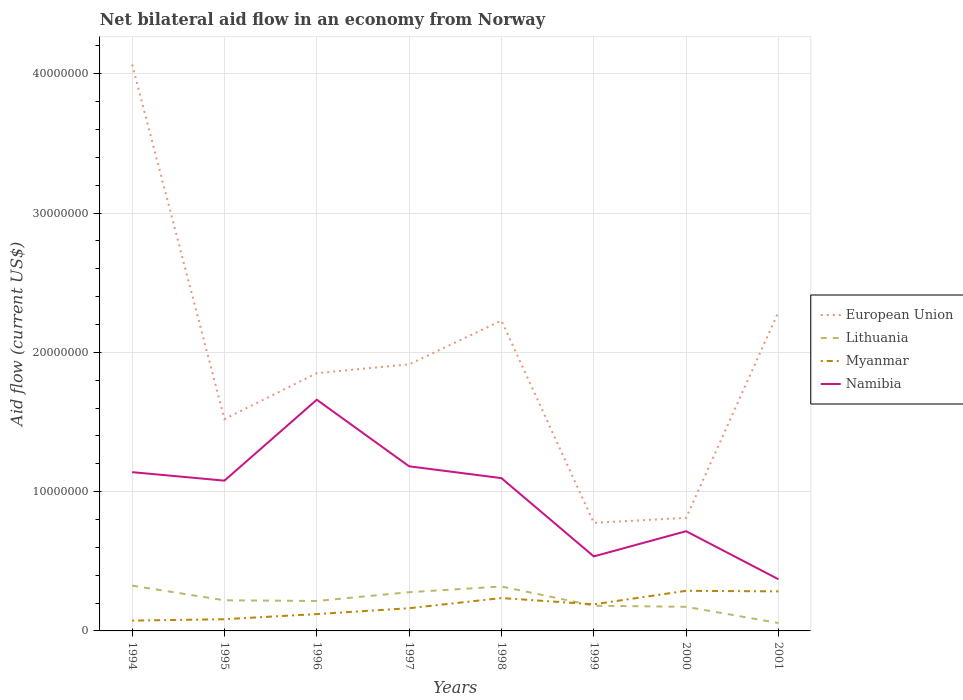Does the line corresponding to European Union intersect with the line corresponding to Lithuania?
Provide a short and direct response. No. Across all years, what is the maximum net bilateral aid flow in Myanmar?
Offer a terse response. 7.40e+05. In which year was the net bilateral aid flow in European Union maximum?
Ensure brevity in your answer.  1999. What is the total net bilateral aid flow in European Union in the graph?
Your answer should be very brief. 7.45e+06. What is the difference between the highest and the second highest net bilateral aid flow in European Union?
Your answer should be very brief. 3.29e+07. What is the difference between the highest and the lowest net bilateral aid flow in Namibia?
Your answer should be very brief. 5. How many lines are there?
Offer a very short reply. 4. What is the title of the graph?
Offer a terse response. Net bilateral aid flow in an economy from Norway. What is the label or title of the X-axis?
Your answer should be very brief. Years. What is the label or title of the Y-axis?
Keep it short and to the point. Aid flow (current US$). What is the Aid flow (current US$) in European Union in 1994?
Provide a succinct answer. 4.07e+07. What is the Aid flow (current US$) in Lithuania in 1994?
Your answer should be compact. 3.25e+06. What is the Aid flow (current US$) of Myanmar in 1994?
Make the answer very short. 7.40e+05. What is the Aid flow (current US$) of Namibia in 1994?
Your response must be concise. 1.14e+07. What is the Aid flow (current US$) of European Union in 1995?
Provide a short and direct response. 1.52e+07. What is the Aid flow (current US$) in Lithuania in 1995?
Give a very brief answer. 2.20e+06. What is the Aid flow (current US$) in Myanmar in 1995?
Your response must be concise. 8.40e+05. What is the Aid flow (current US$) of Namibia in 1995?
Give a very brief answer. 1.08e+07. What is the Aid flow (current US$) in European Union in 1996?
Ensure brevity in your answer.  1.85e+07. What is the Aid flow (current US$) in Lithuania in 1996?
Offer a terse response. 2.15e+06. What is the Aid flow (current US$) in Myanmar in 1996?
Your answer should be very brief. 1.21e+06. What is the Aid flow (current US$) of Namibia in 1996?
Offer a terse response. 1.66e+07. What is the Aid flow (current US$) of European Union in 1997?
Your answer should be very brief. 1.91e+07. What is the Aid flow (current US$) in Lithuania in 1997?
Provide a succinct answer. 2.78e+06. What is the Aid flow (current US$) in Myanmar in 1997?
Your answer should be very brief. 1.63e+06. What is the Aid flow (current US$) in Namibia in 1997?
Provide a short and direct response. 1.18e+07. What is the Aid flow (current US$) of European Union in 1998?
Provide a succinct answer. 2.23e+07. What is the Aid flow (current US$) of Lithuania in 1998?
Provide a succinct answer. 3.19e+06. What is the Aid flow (current US$) of Myanmar in 1998?
Offer a terse response. 2.36e+06. What is the Aid flow (current US$) in Namibia in 1998?
Your response must be concise. 1.10e+07. What is the Aid flow (current US$) in European Union in 1999?
Your response must be concise. 7.76e+06. What is the Aid flow (current US$) in Lithuania in 1999?
Offer a very short reply. 1.81e+06. What is the Aid flow (current US$) in Myanmar in 1999?
Offer a terse response. 1.91e+06. What is the Aid flow (current US$) in Namibia in 1999?
Ensure brevity in your answer.  5.35e+06. What is the Aid flow (current US$) of European Union in 2000?
Keep it short and to the point. 8.12e+06. What is the Aid flow (current US$) of Lithuania in 2000?
Your response must be concise. 1.73e+06. What is the Aid flow (current US$) in Myanmar in 2000?
Make the answer very short. 2.88e+06. What is the Aid flow (current US$) of Namibia in 2000?
Offer a very short reply. 7.16e+06. What is the Aid flow (current US$) of European Union in 2001?
Ensure brevity in your answer.  2.29e+07. What is the Aid flow (current US$) of Lithuania in 2001?
Your answer should be very brief. 5.70e+05. What is the Aid flow (current US$) of Myanmar in 2001?
Provide a succinct answer. 2.84e+06. What is the Aid flow (current US$) of Namibia in 2001?
Keep it short and to the point. 3.71e+06. Across all years, what is the maximum Aid flow (current US$) of European Union?
Your response must be concise. 4.07e+07. Across all years, what is the maximum Aid flow (current US$) in Lithuania?
Make the answer very short. 3.25e+06. Across all years, what is the maximum Aid flow (current US$) of Myanmar?
Give a very brief answer. 2.88e+06. Across all years, what is the maximum Aid flow (current US$) in Namibia?
Offer a very short reply. 1.66e+07. Across all years, what is the minimum Aid flow (current US$) of European Union?
Give a very brief answer. 7.76e+06. Across all years, what is the minimum Aid flow (current US$) in Lithuania?
Make the answer very short. 5.70e+05. Across all years, what is the minimum Aid flow (current US$) in Myanmar?
Your answer should be compact. 7.40e+05. Across all years, what is the minimum Aid flow (current US$) in Namibia?
Make the answer very short. 3.71e+06. What is the total Aid flow (current US$) in European Union in the graph?
Ensure brevity in your answer.  1.55e+08. What is the total Aid flow (current US$) of Lithuania in the graph?
Your response must be concise. 1.77e+07. What is the total Aid flow (current US$) in Myanmar in the graph?
Make the answer very short. 1.44e+07. What is the total Aid flow (current US$) of Namibia in the graph?
Your answer should be compact. 7.78e+07. What is the difference between the Aid flow (current US$) of European Union in 1994 and that in 1995?
Make the answer very short. 2.55e+07. What is the difference between the Aid flow (current US$) of Lithuania in 1994 and that in 1995?
Your response must be concise. 1.05e+06. What is the difference between the Aid flow (current US$) in Myanmar in 1994 and that in 1995?
Provide a succinct answer. -1.00e+05. What is the difference between the Aid flow (current US$) of European Union in 1994 and that in 1996?
Keep it short and to the point. 2.22e+07. What is the difference between the Aid flow (current US$) of Lithuania in 1994 and that in 1996?
Give a very brief answer. 1.10e+06. What is the difference between the Aid flow (current US$) in Myanmar in 1994 and that in 1996?
Provide a succinct answer. -4.70e+05. What is the difference between the Aid flow (current US$) in Namibia in 1994 and that in 1996?
Provide a succinct answer. -5.20e+06. What is the difference between the Aid flow (current US$) of European Union in 1994 and that in 1997?
Offer a very short reply. 2.15e+07. What is the difference between the Aid flow (current US$) in Myanmar in 1994 and that in 1997?
Your response must be concise. -8.90e+05. What is the difference between the Aid flow (current US$) of Namibia in 1994 and that in 1997?
Provide a succinct answer. -4.20e+05. What is the difference between the Aid flow (current US$) in European Union in 1994 and that in 1998?
Provide a succinct answer. 1.84e+07. What is the difference between the Aid flow (current US$) in Myanmar in 1994 and that in 1998?
Ensure brevity in your answer.  -1.62e+06. What is the difference between the Aid flow (current US$) in Namibia in 1994 and that in 1998?
Offer a very short reply. 4.30e+05. What is the difference between the Aid flow (current US$) of European Union in 1994 and that in 1999?
Make the answer very short. 3.29e+07. What is the difference between the Aid flow (current US$) of Lithuania in 1994 and that in 1999?
Provide a succinct answer. 1.44e+06. What is the difference between the Aid flow (current US$) of Myanmar in 1994 and that in 1999?
Ensure brevity in your answer.  -1.17e+06. What is the difference between the Aid flow (current US$) of Namibia in 1994 and that in 1999?
Provide a succinct answer. 6.05e+06. What is the difference between the Aid flow (current US$) in European Union in 1994 and that in 2000?
Provide a short and direct response. 3.26e+07. What is the difference between the Aid flow (current US$) in Lithuania in 1994 and that in 2000?
Offer a terse response. 1.52e+06. What is the difference between the Aid flow (current US$) in Myanmar in 1994 and that in 2000?
Offer a very short reply. -2.14e+06. What is the difference between the Aid flow (current US$) in Namibia in 1994 and that in 2000?
Provide a succinct answer. 4.24e+06. What is the difference between the Aid flow (current US$) in European Union in 1994 and that in 2001?
Provide a short and direct response. 1.78e+07. What is the difference between the Aid flow (current US$) of Lithuania in 1994 and that in 2001?
Offer a very short reply. 2.68e+06. What is the difference between the Aid flow (current US$) in Myanmar in 1994 and that in 2001?
Make the answer very short. -2.10e+06. What is the difference between the Aid flow (current US$) of Namibia in 1994 and that in 2001?
Provide a short and direct response. 7.69e+06. What is the difference between the Aid flow (current US$) in European Union in 1995 and that in 1996?
Ensure brevity in your answer.  -3.30e+06. What is the difference between the Aid flow (current US$) in Lithuania in 1995 and that in 1996?
Your response must be concise. 5.00e+04. What is the difference between the Aid flow (current US$) in Myanmar in 1995 and that in 1996?
Offer a terse response. -3.70e+05. What is the difference between the Aid flow (current US$) of Namibia in 1995 and that in 1996?
Provide a succinct answer. -5.81e+06. What is the difference between the Aid flow (current US$) of European Union in 1995 and that in 1997?
Offer a terse response. -3.93e+06. What is the difference between the Aid flow (current US$) in Lithuania in 1995 and that in 1997?
Your answer should be very brief. -5.80e+05. What is the difference between the Aid flow (current US$) in Myanmar in 1995 and that in 1997?
Offer a terse response. -7.90e+05. What is the difference between the Aid flow (current US$) in Namibia in 1995 and that in 1997?
Offer a terse response. -1.03e+06. What is the difference between the Aid flow (current US$) in European Union in 1995 and that in 1998?
Give a very brief answer. -7.07e+06. What is the difference between the Aid flow (current US$) in Lithuania in 1995 and that in 1998?
Make the answer very short. -9.90e+05. What is the difference between the Aid flow (current US$) in Myanmar in 1995 and that in 1998?
Make the answer very short. -1.52e+06. What is the difference between the Aid flow (current US$) of Namibia in 1995 and that in 1998?
Keep it short and to the point. -1.80e+05. What is the difference between the Aid flow (current US$) in European Union in 1995 and that in 1999?
Offer a terse response. 7.45e+06. What is the difference between the Aid flow (current US$) in Myanmar in 1995 and that in 1999?
Your answer should be compact. -1.07e+06. What is the difference between the Aid flow (current US$) of Namibia in 1995 and that in 1999?
Your answer should be compact. 5.44e+06. What is the difference between the Aid flow (current US$) of European Union in 1995 and that in 2000?
Offer a very short reply. 7.09e+06. What is the difference between the Aid flow (current US$) of Lithuania in 1995 and that in 2000?
Give a very brief answer. 4.70e+05. What is the difference between the Aid flow (current US$) of Myanmar in 1995 and that in 2000?
Make the answer very short. -2.04e+06. What is the difference between the Aid flow (current US$) of Namibia in 1995 and that in 2000?
Make the answer very short. 3.63e+06. What is the difference between the Aid flow (current US$) of European Union in 1995 and that in 2001?
Provide a short and direct response. -7.70e+06. What is the difference between the Aid flow (current US$) of Lithuania in 1995 and that in 2001?
Give a very brief answer. 1.63e+06. What is the difference between the Aid flow (current US$) of Namibia in 1995 and that in 2001?
Your answer should be compact. 7.08e+06. What is the difference between the Aid flow (current US$) of European Union in 1996 and that in 1997?
Keep it short and to the point. -6.30e+05. What is the difference between the Aid flow (current US$) of Lithuania in 1996 and that in 1997?
Ensure brevity in your answer.  -6.30e+05. What is the difference between the Aid flow (current US$) of Myanmar in 1996 and that in 1997?
Ensure brevity in your answer.  -4.20e+05. What is the difference between the Aid flow (current US$) in Namibia in 1996 and that in 1997?
Your answer should be compact. 4.78e+06. What is the difference between the Aid flow (current US$) of European Union in 1996 and that in 1998?
Offer a terse response. -3.77e+06. What is the difference between the Aid flow (current US$) of Lithuania in 1996 and that in 1998?
Give a very brief answer. -1.04e+06. What is the difference between the Aid flow (current US$) of Myanmar in 1996 and that in 1998?
Keep it short and to the point. -1.15e+06. What is the difference between the Aid flow (current US$) in Namibia in 1996 and that in 1998?
Provide a short and direct response. 5.63e+06. What is the difference between the Aid flow (current US$) in European Union in 1996 and that in 1999?
Offer a terse response. 1.08e+07. What is the difference between the Aid flow (current US$) of Myanmar in 1996 and that in 1999?
Offer a terse response. -7.00e+05. What is the difference between the Aid flow (current US$) of Namibia in 1996 and that in 1999?
Provide a short and direct response. 1.12e+07. What is the difference between the Aid flow (current US$) in European Union in 1996 and that in 2000?
Provide a short and direct response. 1.04e+07. What is the difference between the Aid flow (current US$) of Lithuania in 1996 and that in 2000?
Keep it short and to the point. 4.20e+05. What is the difference between the Aid flow (current US$) of Myanmar in 1996 and that in 2000?
Give a very brief answer. -1.67e+06. What is the difference between the Aid flow (current US$) of Namibia in 1996 and that in 2000?
Your response must be concise. 9.44e+06. What is the difference between the Aid flow (current US$) in European Union in 1996 and that in 2001?
Your response must be concise. -4.40e+06. What is the difference between the Aid flow (current US$) in Lithuania in 1996 and that in 2001?
Your answer should be compact. 1.58e+06. What is the difference between the Aid flow (current US$) in Myanmar in 1996 and that in 2001?
Keep it short and to the point. -1.63e+06. What is the difference between the Aid flow (current US$) in Namibia in 1996 and that in 2001?
Your response must be concise. 1.29e+07. What is the difference between the Aid flow (current US$) of European Union in 1997 and that in 1998?
Ensure brevity in your answer.  -3.14e+06. What is the difference between the Aid flow (current US$) of Lithuania in 1997 and that in 1998?
Provide a succinct answer. -4.10e+05. What is the difference between the Aid flow (current US$) in Myanmar in 1997 and that in 1998?
Offer a terse response. -7.30e+05. What is the difference between the Aid flow (current US$) in Namibia in 1997 and that in 1998?
Offer a terse response. 8.50e+05. What is the difference between the Aid flow (current US$) of European Union in 1997 and that in 1999?
Your response must be concise. 1.14e+07. What is the difference between the Aid flow (current US$) in Lithuania in 1997 and that in 1999?
Offer a very short reply. 9.70e+05. What is the difference between the Aid flow (current US$) of Myanmar in 1997 and that in 1999?
Your response must be concise. -2.80e+05. What is the difference between the Aid flow (current US$) of Namibia in 1997 and that in 1999?
Give a very brief answer. 6.47e+06. What is the difference between the Aid flow (current US$) of European Union in 1997 and that in 2000?
Make the answer very short. 1.10e+07. What is the difference between the Aid flow (current US$) of Lithuania in 1997 and that in 2000?
Your response must be concise. 1.05e+06. What is the difference between the Aid flow (current US$) of Myanmar in 1997 and that in 2000?
Give a very brief answer. -1.25e+06. What is the difference between the Aid flow (current US$) in Namibia in 1997 and that in 2000?
Provide a short and direct response. 4.66e+06. What is the difference between the Aid flow (current US$) of European Union in 1997 and that in 2001?
Offer a terse response. -3.77e+06. What is the difference between the Aid flow (current US$) in Lithuania in 1997 and that in 2001?
Ensure brevity in your answer.  2.21e+06. What is the difference between the Aid flow (current US$) of Myanmar in 1997 and that in 2001?
Your answer should be very brief. -1.21e+06. What is the difference between the Aid flow (current US$) in Namibia in 1997 and that in 2001?
Your response must be concise. 8.11e+06. What is the difference between the Aid flow (current US$) of European Union in 1998 and that in 1999?
Provide a succinct answer. 1.45e+07. What is the difference between the Aid flow (current US$) of Lithuania in 1998 and that in 1999?
Ensure brevity in your answer.  1.38e+06. What is the difference between the Aid flow (current US$) in Namibia in 1998 and that in 1999?
Your answer should be compact. 5.62e+06. What is the difference between the Aid flow (current US$) of European Union in 1998 and that in 2000?
Give a very brief answer. 1.42e+07. What is the difference between the Aid flow (current US$) in Lithuania in 1998 and that in 2000?
Keep it short and to the point. 1.46e+06. What is the difference between the Aid flow (current US$) in Myanmar in 1998 and that in 2000?
Give a very brief answer. -5.20e+05. What is the difference between the Aid flow (current US$) of Namibia in 1998 and that in 2000?
Offer a terse response. 3.81e+06. What is the difference between the Aid flow (current US$) of European Union in 1998 and that in 2001?
Your answer should be compact. -6.30e+05. What is the difference between the Aid flow (current US$) in Lithuania in 1998 and that in 2001?
Provide a succinct answer. 2.62e+06. What is the difference between the Aid flow (current US$) in Myanmar in 1998 and that in 2001?
Provide a succinct answer. -4.80e+05. What is the difference between the Aid flow (current US$) of Namibia in 1998 and that in 2001?
Make the answer very short. 7.26e+06. What is the difference between the Aid flow (current US$) in European Union in 1999 and that in 2000?
Provide a succinct answer. -3.60e+05. What is the difference between the Aid flow (current US$) of Lithuania in 1999 and that in 2000?
Your response must be concise. 8.00e+04. What is the difference between the Aid flow (current US$) of Myanmar in 1999 and that in 2000?
Provide a short and direct response. -9.70e+05. What is the difference between the Aid flow (current US$) of Namibia in 1999 and that in 2000?
Offer a terse response. -1.81e+06. What is the difference between the Aid flow (current US$) in European Union in 1999 and that in 2001?
Make the answer very short. -1.52e+07. What is the difference between the Aid flow (current US$) in Lithuania in 1999 and that in 2001?
Provide a succinct answer. 1.24e+06. What is the difference between the Aid flow (current US$) in Myanmar in 1999 and that in 2001?
Provide a short and direct response. -9.30e+05. What is the difference between the Aid flow (current US$) in Namibia in 1999 and that in 2001?
Provide a succinct answer. 1.64e+06. What is the difference between the Aid flow (current US$) in European Union in 2000 and that in 2001?
Offer a very short reply. -1.48e+07. What is the difference between the Aid flow (current US$) in Lithuania in 2000 and that in 2001?
Your answer should be compact. 1.16e+06. What is the difference between the Aid flow (current US$) in Myanmar in 2000 and that in 2001?
Keep it short and to the point. 4.00e+04. What is the difference between the Aid flow (current US$) of Namibia in 2000 and that in 2001?
Offer a very short reply. 3.45e+06. What is the difference between the Aid flow (current US$) in European Union in 1994 and the Aid flow (current US$) in Lithuania in 1995?
Your answer should be very brief. 3.85e+07. What is the difference between the Aid flow (current US$) of European Union in 1994 and the Aid flow (current US$) of Myanmar in 1995?
Offer a terse response. 3.98e+07. What is the difference between the Aid flow (current US$) of European Union in 1994 and the Aid flow (current US$) of Namibia in 1995?
Provide a succinct answer. 2.99e+07. What is the difference between the Aid flow (current US$) in Lithuania in 1994 and the Aid flow (current US$) in Myanmar in 1995?
Provide a succinct answer. 2.41e+06. What is the difference between the Aid flow (current US$) in Lithuania in 1994 and the Aid flow (current US$) in Namibia in 1995?
Your answer should be very brief. -7.54e+06. What is the difference between the Aid flow (current US$) of Myanmar in 1994 and the Aid flow (current US$) of Namibia in 1995?
Offer a terse response. -1.00e+07. What is the difference between the Aid flow (current US$) of European Union in 1994 and the Aid flow (current US$) of Lithuania in 1996?
Your answer should be very brief. 3.85e+07. What is the difference between the Aid flow (current US$) of European Union in 1994 and the Aid flow (current US$) of Myanmar in 1996?
Give a very brief answer. 3.95e+07. What is the difference between the Aid flow (current US$) in European Union in 1994 and the Aid flow (current US$) in Namibia in 1996?
Make the answer very short. 2.41e+07. What is the difference between the Aid flow (current US$) in Lithuania in 1994 and the Aid flow (current US$) in Myanmar in 1996?
Your response must be concise. 2.04e+06. What is the difference between the Aid flow (current US$) of Lithuania in 1994 and the Aid flow (current US$) of Namibia in 1996?
Your answer should be very brief. -1.34e+07. What is the difference between the Aid flow (current US$) of Myanmar in 1994 and the Aid flow (current US$) of Namibia in 1996?
Your response must be concise. -1.59e+07. What is the difference between the Aid flow (current US$) in European Union in 1994 and the Aid flow (current US$) in Lithuania in 1997?
Ensure brevity in your answer.  3.79e+07. What is the difference between the Aid flow (current US$) in European Union in 1994 and the Aid flow (current US$) in Myanmar in 1997?
Ensure brevity in your answer.  3.90e+07. What is the difference between the Aid flow (current US$) of European Union in 1994 and the Aid flow (current US$) of Namibia in 1997?
Keep it short and to the point. 2.88e+07. What is the difference between the Aid flow (current US$) in Lithuania in 1994 and the Aid flow (current US$) in Myanmar in 1997?
Keep it short and to the point. 1.62e+06. What is the difference between the Aid flow (current US$) of Lithuania in 1994 and the Aid flow (current US$) of Namibia in 1997?
Your answer should be very brief. -8.57e+06. What is the difference between the Aid flow (current US$) in Myanmar in 1994 and the Aid flow (current US$) in Namibia in 1997?
Give a very brief answer. -1.11e+07. What is the difference between the Aid flow (current US$) in European Union in 1994 and the Aid flow (current US$) in Lithuania in 1998?
Provide a short and direct response. 3.75e+07. What is the difference between the Aid flow (current US$) of European Union in 1994 and the Aid flow (current US$) of Myanmar in 1998?
Give a very brief answer. 3.83e+07. What is the difference between the Aid flow (current US$) of European Union in 1994 and the Aid flow (current US$) of Namibia in 1998?
Your answer should be very brief. 2.97e+07. What is the difference between the Aid flow (current US$) in Lithuania in 1994 and the Aid flow (current US$) in Myanmar in 1998?
Offer a terse response. 8.90e+05. What is the difference between the Aid flow (current US$) of Lithuania in 1994 and the Aid flow (current US$) of Namibia in 1998?
Make the answer very short. -7.72e+06. What is the difference between the Aid flow (current US$) of Myanmar in 1994 and the Aid flow (current US$) of Namibia in 1998?
Keep it short and to the point. -1.02e+07. What is the difference between the Aid flow (current US$) in European Union in 1994 and the Aid flow (current US$) in Lithuania in 1999?
Provide a short and direct response. 3.89e+07. What is the difference between the Aid flow (current US$) in European Union in 1994 and the Aid flow (current US$) in Myanmar in 1999?
Your response must be concise. 3.88e+07. What is the difference between the Aid flow (current US$) of European Union in 1994 and the Aid flow (current US$) of Namibia in 1999?
Offer a terse response. 3.53e+07. What is the difference between the Aid flow (current US$) in Lithuania in 1994 and the Aid flow (current US$) in Myanmar in 1999?
Give a very brief answer. 1.34e+06. What is the difference between the Aid flow (current US$) of Lithuania in 1994 and the Aid flow (current US$) of Namibia in 1999?
Ensure brevity in your answer.  -2.10e+06. What is the difference between the Aid flow (current US$) of Myanmar in 1994 and the Aid flow (current US$) of Namibia in 1999?
Provide a succinct answer. -4.61e+06. What is the difference between the Aid flow (current US$) in European Union in 1994 and the Aid flow (current US$) in Lithuania in 2000?
Ensure brevity in your answer.  3.89e+07. What is the difference between the Aid flow (current US$) in European Union in 1994 and the Aid flow (current US$) in Myanmar in 2000?
Ensure brevity in your answer.  3.78e+07. What is the difference between the Aid flow (current US$) in European Union in 1994 and the Aid flow (current US$) in Namibia in 2000?
Give a very brief answer. 3.35e+07. What is the difference between the Aid flow (current US$) in Lithuania in 1994 and the Aid flow (current US$) in Namibia in 2000?
Your answer should be compact. -3.91e+06. What is the difference between the Aid flow (current US$) in Myanmar in 1994 and the Aid flow (current US$) in Namibia in 2000?
Provide a succinct answer. -6.42e+06. What is the difference between the Aid flow (current US$) in European Union in 1994 and the Aid flow (current US$) in Lithuania in 2001?
Provide a succinct answer. 4.01e+07. What is the difference between the Aid flow (current US$) of European Union in 1994 and the Aid flow (current US$) of Myanmar in 2001?
Offer a terse response. 3.78e+07. What is the difference between the Aid flow (current US$) of European Union in 1994 and the Aid flow (current US$) of Namibia in 2001?
Make the answer very short. 3.70e+07. What is the difference between the Aid flow (current US$) of Lithuania in 1994 and the Aid flow (current US$) of Myanmar in 2001?
Provide a short and direct response. 4.10e+05. What is the difference between the Aid flow (current US$) in Lithuania in 1994 and the Aid flow (current US$) in Namibia in 2001?
Offer a terse response. -4.60e+05. What is the difference between the Aid flow (current US$) of Myanmar in 1994 and the Aid flow (current US$) of Namibia in 2001?
Your answer should be compact. -2.97e+06. What is the difference between the Aid flow (current US$) of European Union in 1995 and the Aid flow (current US$) of Lithuania in 1996?
Your response must be concise. 1.31e+07. What is the difference between the Aid flow (current US$) in European Union in 1995 and the Aid flow (current US$) in Myanmar in 1996?
Make the answer very short. 1.40e+07. What is the difference between the Aid flow (current US$) of European Union in 1995 and the Aid flow (current US$) of Namibia in 1996?
Make the answer very short. -1.39e+06. What is the difference between the Aid flow (current US$) of Lithuania in 1995 and the Aid flow (current US$) of Myanmar in 1996?
Your answer should be very brief. 9.90e+05. What is the difference between the Aid flow (current US$) in Lithuania in 1995 and the Aid flow (current US$) in Namibia in 1996?
Provide a succinct answer. -1.44e+07. What is the difference between the Aid flow (current US$) in Myanmar in 1995 and the Aid flow (current US$) in Namibia in 1996?
Provide a short and direct response. -1.58e+07. What is the difference between the Aid flow (current US$) of European Union in 1995 and the Aid flow (current US$) of Lithuania in 1997?
Keep it short and to the point. 1.24e+07. What is the difference between the Aid flow (current US$) of European Union in 1995 and the Aid flow (current US$) of Myanmar in 1997?
Offer a very short reply. 1.36e+07. What is the difference between the Aid flow (current US$) in European Union in 1995 and the Aid flow (current US$) in Namibia in 1997?
Your answer should be very brief. 3.39e+06. What is the difference between the Aid flow (current US$) of Lithuania in 1995 and the Aid flow (current US$) of Myanmar in 1997?
Ensure brevity in your answer.  5.70e+05. What is the difference between the Aid flow (current US$) of Lithuania in 1995 and the Aid flow (current US$) of Namibia in 1997?
Provide a short and direct response. -9.62e+06. What is the difference between the Aid flow (current US$) of Myanmar in 1995 and the Aid flow (current US$) of Namibia in 1997?
Keep it short and to the point. -1.10e+07. What is the difference between the Aid flow (current US$) in European Union in 1995 and the Aid flow (current US$) in Lithuania in 1998?
Your answer should be compact. 1.20e+07. What is the difference between the Aid flow (current US$) in European Union in 1995 and the Aid flow (current US$) in Myanmar in 1998?
Provide a short and direct response. 1.28e+07. What is the difference between the Aid flow (current US$) in European Union in 1995 and the Aid flow (current US$) in Namibia in 1998?
Your answer should be compact. 4.24e+06. What is the difference between the Aid flow (current US$) in Lithuania in 1995 and the Aid flow (current US$) in Namibia in 1998?
Give a very brief answer. -8.77e+06. What is the difference between the Aid flow (current US$) in Myanmar in 1995 and the Aid flow (current US$) in Namibia in 1998?
Give a very brief answer. -1.01e+07. What is the difference between the Aid flow (current US$) of European Union in 1995 and the Aid flow (current US$) of Lithuania in 1999?
Offer a terse response. 1.34e+07. What is the difference between the Aid flow (current US$) in European Union in 1995 and the Aid flow (current US$) in Myanmar in 1999?
Make the answer very short. 1.33e+07. What is the difference between the Aid flow (current US$) of European Union in 1995 and the Aid flow (current US$) of Namibia in 1999?
Your answer should be very brief. 9.86e+06. What is the difference between the Aid flow (current US$) of Lithuania in 1995 and the Aid flow (current US$) of Namibia in 1999?
Keep it short and to the point. -3.15e+06. What is the difference between the Aid flow (current US$) in Myanmar in 1995 and the Aid flow (current US$) in Namibia in 1999?
Provide a short and direct response. -4.51e+06. What is the difference between the Aid flow (current US$) of European Union in 1995 and the Aid flow (current US$) of Lithuania in 2000?
Offer a terse response. 1.35e+07. What is the difference between the Aid flow (current US$) of European Union in 1995 and the Aid flow (current US$) of Myanmar in 2000?
Provide a short and direct response. 1.23e+07. What is the difference between the Aid flow (current US$) in European Union in 1995 and the Aid flow (current US$) in Namibia in 2000?
Offer a very short reply. 8.05e+06. What is the difference between the Aid flow (current US$) of Lithuania in 1995 and the Aid flow (current US$) of Myanmar in 2000?
Provide a short and direct response. -6.80e+05. What is the difference between the Aid flow (current US$) in Lithuania in 1995 and the Aid flow (current US$) in Namibia in 2000?
Your answer should be compact. -4.96e+06. What is the difference between the Aid flow (current US$) in Myanmar in 1995 and the Aid flow (current US$) in Namibia in 2000?
Offer a terse response. -6.32e+06. What is the difference between the Aid flow (current US$) in European Union in 1995 and the Aid flow (current US$) in Lithuania in 2001?
Your response must be concise. 1.46e+07. What is the difference between the Aid flow (current US$) in European Union in 1995 and the Aid flow (current US$) in Myanmar in 2001?
Make the answer very short. 1.24e+07. What is the difference between the Aid flow (current US$) in European Union in 1995 and the Aid flow (current US$) in Namibia in 2001?
Your answer should be very brief. 1.15e+07. What is the difference between the Aid flow (current US$) of Lithuania in 1995 and the Aid flow (current US$) of Myanmar in 2001?
Your response must be concise. -6.40e+05. What is the difference between the Aid flow (current US$) of Lithuania in 1995 and the Aid flow (current US$) of Namibia in 2001?
Provide a succinct answer. -1.51e+06. What is the difference between the Aid flow (current US$) in Myanmar in 1995 and the Aid flow (current US$) in Namibia in 2001?
Provide a short and direct response. -2.87e+06. What is the difference between the Aid flow (current US$) in European Union in 1996 and the Aid flow (current US$) in Lithuania in 1997?
Keep it short and to the point. 1.57e+07. What is the difference between the Aid flow (current US$) in European Union in 1996 and the Aid flow (current US$) in Myanmar in 1997?
Give a very brief answer. 1.69e+07. What is the difference between the Aid flow (current US$) of European Union in 1996 and the Aid flow (current US$) of Namibia in 1997?
Keep it short and to the point. 6.69e+06. What is the difference between the Aid flow (current US$) of Lithuania in 1996 and the Aid flow (current US$) of Myanmar in 1997?
Ensure brevity in your answer.  5.20e+05. What is the difference between the Aid flow (current US$) in Lithuania in 1996 and the Aid flow (current US$) in Namibia in 1997?
Provide a short and direct response. -9.67e+06. What is the difference between the Aid flow (current US$) of Myanmar in 1996 and the Aid flow (current US$) of Namibia in 1997?
Your response must be concise. -1.06e+07. What is the difference between the Aid flow (current US$) in European Union in 1996 and the Aid flow (current US$) in Lithuania in 1998?
Make the answer very short. 1.53e+07. What is the difference between the Aid flow (current US$) in European Union in 1996 and the Aid flow (current US$) in Myanmar in 1998?
Offer a terse response. 1.62e+07. What is the difference between the Aid flow (current US$) of European Union in 1996 and the Aid flow (current US$) of Namibia in 1998?
Provide a short and direct response. 7.54e+06. What is the difference between the Aid flow (current US$) in Lithuania in 1996 and the Aid flow (current US$) in Myanmar in 1998?
Your response must be concise. -2.10e+05. What is the difference between the Aid flow (current US$) in Lithuania in 1996 and the Aid flow (current US$) in Namibia in 1998?
Give a very brief answer. -8.82e+06. What is the difference between the Aid flow (current US$) of Myanmar in 1996 and the Aid flow (current US$) of Namibia in 1998?
Ensure brevity in your answer.  -9.76e+06. What is the difference between the Aid flow (current US$) of European Union in 1996 and the Aid flow (current US$) of Lithuania in 1999?
Provide a short and direct response. 1.67e+07. What is the difference between the Aid flow (current US$) in European Union in 1996 and the Aid flow (current US$) in Myanmar in 1999?
Your answer should be very brief. 1.66e+07. What is the difference between the Aid flow (current US$) in European Union in 1996 and the Aid flow (current US$) in Namibia in 1999?
Your answer should be compact. 1.32e+07. What is the difference between the Aid flow (current US$) of Lithuania in 1996 and the Aid flow (current US$) of Namibia in 1999?
Keep it short and to the point. -3.20e+06. What is the difference between the Aid flow (current US$) of Myanmar in 1996 and the Aid flow (current US$) of Namibia in 1999?
Your answer should be compact. -4.14e+06. What is the difference between the Aid flow (current US$) of European Union in 1996 and the Aid flow (current US$) of Lithuania in 2000?
Keep it short and to the point. 1.68e+07. What is the difference between the Aid flow (current US$) of European Union in 1996 and the Aid flow (current US$) of Myanmar in 2000?
Your answer should be very brief. 1.56e+07. What is the difference between the Aid flow (current US$) in European Union in 1996 and the Aid flow (current US$) in Namibia in 2000?
Your answer should be compact. 1.14e+07. What is the difference between the Aid flow (current US$) in Lithuania in 1996 and the Aid flow (current US$) in Myanmar in 2000?
Your answer should be very brief. -7.30e+05. What is the difference between the Aid flow (current US$) in Lithuania in 1996 and the Aid flow (current US$) in Namibia in 2000?
Keep it short and to the point. -5.01e+06. What is the difference between the Aid flow (current US$) of Myanmar in 1996 and the Aid flow (current US$) of Namibia in 2000?
Offer a very short reply. -5.95e+06. What is the difference between the Aid flow (current US$) in European Union in 1996 and the Aid flow (current US$) in Lithuania in 2001?
Your answer should be compact. 1.79e+07. What is the difference between the Aid flow (current US$) in European Union in 1996 and the Aid flow (current US$) in Myanmar in 2001?
Ensure brevity in your answer.  1.57e+07. What is the difference between the Aid flow (current US$) in European Union in 1996 and the Aid flow (current US$) in Namibia in 2001?
Your response must be concise. 1.48e+07. What is the difference between the Aid flow (current US$) in Lithuania in 1996 and the Aid flow (current US$) in Myanmar in 2001?
Keep it short and to the point. -6.90e+05. What is the difference between the Aid flow (current US$) in Lithuania in 1996 and the Aid flow (current US$) in Namibia in 2001?
Provide a succinct answer. -1.56e+06. What is the difference between the Aid flow (current US$) in Myanmar in 1996 and the Aid flow (current US$) in Namibia in 2001?
Provide a short and direct response. -2.50e+06. What is the difference between the Aid flow (current US$) in European Union in 1997 and the Aid flow (current US$) in Lithuania in 1998?
Provide a succinct answer. 1.60e+07. What is the difference between the Aid flow (current US$) of European Union in 1997 and the Aid flow (current US$) of Myanmar in 1998?
Offer a very short reply. 1.68e+07. What is the difference between the Aid flow (current US$) of European Union in 1997 and the Aid flow (current US$) of Namibia in 1998?
Provide a succinct answer. 8.17e+06. What is the difference between the Aid flow (current US$) in Lithuania in 1997 and the Aid flow (current US$) in Myanmar in 1998?
Provide a short and direct response. 4.20e+05. What is the difference between the Aid flow (current US$) in Lithuania in 1997 and the Aid flow (current US$) in Namibia in 1998?
Provide a succinct answer. -8.19e+06. What is the difference between the Aid flow (current US$) of Myanmar in 1997 and the Aid flow (current US$) of Namibia in 1998?
Provide a succinct answer. -9.34e+06. What is the difference between the Aid flow (current US$) of European Union in 1997 and the Aid flow (current US$) of Lithuania in 1999?
Ensure brevity in your answer.  1.73e+07. What is the difference between the Aid flow (current US$) in European Union in 1997 and the Aid flow (current US$) in Myanmar in 1999?
Your answer should be compact. 1.72e+07. What is the difference between the Aid flow (current US$) of European Union in 1997 and the Aid flow (current US$) of Namibia in 1999?
Give a very brief answer. 1.38e+07. What is the difference between the Aid flow (current US$) in Lithuania in 1997 and the Aid flow (current US$) in Myanmar in 1999?
Provide a short and direct response. 8.70e+05. What is the difference between the Aid flow (current US$) of Lithuania in 1997 and the Aid flow (current US$) of Namibia in 1999?
Provide a short and direct response. -2.57e+06. What is the difference between the Aid flow (current US$) of Myanmar in 1997 and the Aid flow (current US$) of Namibia in 1999?
Your response must be concise. -3.72e+06. What is the difference between the Aid flow (current US$) of European Union in 1997 and the Aid flow (current US$) of Lithuania in 2000?
Offer a very short reply. 1.74e+07. What is the difference between the Aid flow (current US$) in European Union in 1997 and the Aid flow (current US$) in Myanmar in 2000?
Offer a terse response. 1.63e+07. What is the difference between the Aid flow (current US$) of European Union in 1997 and the Aid flow (current US$) of Namibia in 2000?
Ensure brevity in your answer.  1.20e+07. What is the difference between the Aid flow (current US$) in Lithuania in 1997 and the Aid flow (current US$) in Namibia in 2000?
Keep it short and to the point. -4.38e+06. What is the difference between the Aid flow (current US$) in Myanmar in 1997 and the Aid flow (current US$) in Namibia in 2000?
Provide a short and direct response. -5.53e+06. What is the difference between the Aid flow (current US$) of European Union in 1997 and the Aid flow (current US$) of Lithuania in 2001?
Your answer should be very brief. 1.86e+07. What is the difference between the Aid flow (current US$) of European Union in 1997 and the Aid flow (current US$) of Myanmar in 2001?
Your answer should be compact. 1.63e+07. What is the difference between the Aid flow (current US$) in European Union in 1997 and the Aid flow (current US$) in Namibia in 2001?
Make the answer very short. 1.54e+07. What is the difference between the Aid flow (current US$) of Lithuania in 1997 and the Aid flow (current US$) of Myanmar in 2001?
Make the answer very short. -6.00e+04. What is the difference between the Aid flow (current US$) of Lithuania in 1997 and the Aid flow (current US$) of Namibia in 2001?
Keep it short and to the point. -9.30e+05. What is the difference between the Aid flow (current US$) of Myanmar in 1997 and the Aid flow (current US$) of Namibia in 2001?
Provide a succinct answer. -2.08e+06. What is the difference between the Aid flow (current US$) in European Union in 1998 and the Aid flow (current US$) in Lithuania in 1999?
Offer a very short reply. 2.05e+07. What is the difference between the Aid flow (current US$) in European Union in 1998 and the Aid flow (current US$) in Myanmar in 1999?
Your answer should be very brief. 2.04e+07. What is the difference between the Aid flow (current US$) in European Union in 1998 and the Aid flow (current US$) in Namibia in 1999?
Provide a short and direct response. 1.69e+07. What is the difference between the Aid flow (current US$) in Lithuania in 1998 and the Aid flow (current US$) in Myanmar in 1999?
Your answer should be compact. 1.28e+06. What is the difference between the Aid flow (current US$) of Lithuania in 1998 and the Aid flow (current US$) of Namibia in 1999?
Give a very brief answer. -2.16e+06. What is the difference between the Aid flow (current US$) of Myanmar in 1998 and the Aid flow (current US$) of Namibia in 1999?
Your response must be concise. -2.99e+06. What is the difference between the Aid flow (current US$) in European Union in 1998 and the Aid flow (current US$) in Lithuania in 2000?
Offer a very short reply. 2.06e+07. What is the difference between the Aid flow (current US$) in European Union in 1998 and the Aid flow (current US$) in Myanmar in 2000?
Offer a terse response. 1.94e+07. What is the difference between the Aid flow (current US$) of European Union in 1998 and the Aid flow (current US$) of Namibia in 2000?
Keep it short and to the point. 1.51e+07. What is the difference between the Aid flow (current US$) in Lithuania in 1998 and the Aid flow (current US$) in Namibia in 2000?
Offer a terse response. -3.97e+06. What is the difference between the Aid flow (current US$) in Myanmar in 1998 and the Aid flow (current US$) in Namibia in 2000?
Keep it short and to the point. -4.80e+06. What is the difference between the Aid flow (current US$) of European Union in 1998 and the Aid flow (current US$) of Lithuania in 2001?
Your answer should be very brief. 2.17e+07. What is the difference between the Aid flow (current US$) in European Union in 1998 and the Aid flow (current US$) in Myanmar in 2001?
Your answer should be compact. 1.94e+07. What is the difference between the Aid flow (current US$) in European Union in 1998 and the Aid flow (current US$) in Namibia in 2001?
Your answer should be very brief. 1.86e+07. What is the difference between the Aid flow (current US$) of Lithuania in 1998 and the Aid flow (current US$) of Myanmar in 2001?
Keep it short and to the point. 3.50e+05. What is the difference between the Aid flow (current US$) of Lithuania in 1998 and the Aid flow (current US$) of Namibia in 2001?
Your answer should be very brief. -5.20e+05. What is the difference between the Aid flow (current US$) in Myanmar in 1998 and the Aid flow (current US$) in Namibia in 2001?
Provide a short and direct response. -1.35e+06. What is the difference between the Aid flow (current US$) in European Union in 1999 and the Aid flow (current US$) in Lithuania in 2000?
Ensure brevity in your answer.  6.03e+06. What is the difference between the Aid flow (current US$) of European Union in 1999 and the Aid flow (current US$) of Myanmar in 2000?
Your answer should be very brief. 4.88e+06. What is the difference between the Aid flow (current US$) of Lithuania in 1999 and the Aid flow (current US$) of Myanmar in 2000?
Make the answer very short. -1.07e+06. What is the difference between the Aid flow (current US$) in Lithuania in 1999 and the Aid flow (current US$) in Namibia in 2000?
Provide a short and direct response. -5.35e+06. What is the difference between the Aid flow (current US$) of Myanmar in 1999 and the Aid flow (current US$) of Namibia in 2000?
Offer a terse response. -5.25e+06. What is the difference between the Aid flow (current US$) of European Union in 1999 and the Aid flow (current US$) of Lithuania in 2001?
Offer a very short reply. 7.19e+06. What is the difference between the Aid flow (current US$) in European Union in 1999 and the Aid flow (current US$) in Myanmar in 2001?
Offer a terse response. 4.92e+06. What is the difference between the Aid flow (current US$) in European Union in 1999 and the Aid flow (current US$) in Namibia in 2001?
Give a very brief answer. 4.05e+06. What is the difference between the Aid flow (current US$) of Lithuania in 1999 and the Aid flow (current US$) of Myanmar in 2001?
Provide a succinct answer. -1.03e+06. What is the difference between the Aid flow (current US$) of Lithuania in 1999 and the Aid flow (current US$) of Namibia in 2001?
Ensure brevity in your answer.  -1.90e+06. What is the difference between the Aid flow (current US$) in Myanmar in 1999 and the Aid flow (current US$) in Namibia in 2001?
Your answer should be very brief. -1.80e+06. What is the difference between the Aid flow (current US$) in European Union in 2000 and the Aid flow (current US$) in Lithuania in 2001?
Offer a terse response. 7.55e+06. What is the difference between the Aid flow (current US$) of European Union in 2000 and the Aid flow (current US$) of Myanmar in 2001?
Ensure brevity in your answer.  5.28e+06. What is the difference between the Aid flow (current US$) of European Union in 2000 and the Aid flow (current US$) of Namibia in 2001?
Ensure brevity in your answer.  4.41e+06. What is the difference between the Aid flow (current US$) of Lithuania in 2000 and the Aid flow (current US$) of Myanmar in 2001?
Provide a short and direct response. -1.11e+06. What is the difference between the Aid flow (current US$) of Lithuania in 2000 and the Aid flow (current US$) of Namibia in 2001?
Make the answer very short. -1.98e+06. What is the difference between the Aid flow (current US$) in Myanmar in 2000 and the Aid flow (current US$) in Namibia in 2001?
Give a very brief answer. -8.30e+05. What is the average Aid flow (current US$) in European Union per year?
Give a very brief answer. 1.93e+07. What is the average Aid flow (current US$) of Lithuania per year?
Provide a succinct answer. 2.21e+06. What is the average Aid flow (current US$) of Myanmar per year?
Make the answer very short. 1.80e+06. What is the average Aid flow (current US$) in Namibia per year?
Provide a short and direct response. 9.72e+06. In the year 1994, what is the difference between the Aid flow (current US$) of European Union and Aid flow (current US$) of Lithuania?
Your response must be concise. 3.74e+07. In the year 1994, what is the difference between the Aid flow (current US$) in European Union and Aid flow (current US$) in Myanmar?
Make the answer very short. 3.99e+07. In the year 1994, what is the difference between the Aid flow (current US$) of European Union and Aid flow (current US$) of Namibia?
Make the answer very short. 2.93e+07. In the year 1994, what is the difference between the Aid flow (current US$) of Lithuania and Aid flow (current US$) of Myanmar?
Your answer should be compact. 2.51e+06. In the year 1994, what is the difference between the Aid flow (current US$) of Lithuania and Aid flow (current US$) of Namibia?
Ensure brevity in your answer.  -8.15e+06. In the year 1994, what is the difference between the Aid flow (current US$) of Myanmar and Aid flow (current US$) of Namibia?
Your response must be concise. -1.07e+07. In the year 1995, what is the difference between the Aid flow (current US$) in European Union and Aid flow (current US$) in Lithuania?
Give a very brief answer. 1.30e+07. In the year 1995, what is the difference between the Aid flow (current US$) in European Union and Aid flow (current US$) in Myanmar?
Provide a succinct answer. 1.44e+07. In the year 1995, what is the difference between the Aid flow (current US$) in European Union and Aid flow (current US$) in Namibia?
Make the answer very short. 4.42e+06. In the year 1995, what is the difference between the Aid flow (current US$) in Lithuania and Aid flow (current US$) in Myanmar?
Your answer should be very brief. 1.36e+06. In the year 1995, what is the difference between the Aid flow (current US$) in Lithuania and Aid flow (current US$) in Namibia?
Give a very brief answer. -8.59e+06. In the year 1995, what is the difference between the Aid flow (current US$) in Myanmar and Aid flow (current US$) in Namibia?
Make the answer very short. -9.95e+06. In the year 1996, what is the difference between the Aid flow (current US$) in European Union and Aid flow (current US$) in Lithuania?
Keep it short and to the point. 1.64e+07. In the year 1996, what is the difference between the Aid flow (current US$) of European Union and Aid flow (current US$) of Myanmar?
Ensure brevity in your answer.  1.73e+07. In the year 1996, what is the difference between the Aid flow (current US$) in European Union and Aid flow (current US$) in Namibia?
Ensure brevity in your answer.  1.91e+06. In the year 1996, what is the difference between the Aid flow (current US$) in Lithuania and Aid flow (current US$) in Myanmar?
Your answer should be very brief. 9.40e+05. In the year 1996, what is the difference between the Aid flow (current US$) of Lithuania and Aid flow (current US$) of Namibia?
Keep it short and to the point. -1.44e+07. In the year 1996, what is the difference between the Aid flow (current US$) of Myanmar and Aid flow (current US$) of Namibia?
Your answer should be compact. -1.54e+07. In the year 1997, what is the difference between the Aid flow (current US$) of European Union and Aid flow (current US$) of Lithuania?
Your answer should be very brief. 1.64e+07. In the year 1997, what is the difference between the Aid flow (current US$) in European Union and Aid flow (current US$) in Myanmar?
Keep it short and to the point. 1.75e+07. In the year 1997, what is the difference between the Aid flow (current US$) of European Union and Aid flow (current US$) of Namibia?
Your response must be concise. 7.32e+06. In the year 1997, what is the difference between the Aid flow (current US$) of Lithuania and Aid flow (current US$) of Myanmar?
Provide a short and direct response. 1.15e+06. In the year 1997, what is the difference between the Aid flow (current US$) of Lithuania and Aid flow (current US$) of Namibia?
Provide a short and direct response. -9.04e+06. In the year 1997, what is the difference between the Aid flow (current US$) of Myanmar and Aid flow (current US$) of Namibia?
Your answer should be compact. -1.02e+07. In the year 1998, what is the difference between the Aid flow (current US$) in European Union and Aid flow (current US$) in Lithuania?
Give a very brief answer. 1.91e+07. In the year 1998, what is the difference between the Aid flow (current US$) of European Union and Aid flow (current US$) of Myanmar?
Your answer should be compact. 1.99e+07. In the year 1998, what is the difference between the Aid flow (current US$) of European Union and Aid flow (current US$) of Namibia?
Offer a very short reply. 1.13e+07. In the year 1998, what is the difference between the Aid flow (current US$) of Lithuania and Aid flow (current US$) of Myanmar?
Offer a very short reply. 8.30e+05. In the year 1998, what is the difference between the Aid flow (current US$) of Lithuania and Aid flow (current US$) of Namibia?
Your answer should be very brief. -7.78e+06. In the year 1998, what is the difference between the Aid flow (current US$) in Myanmar and Aid flow (current US$) in Namibia?
Offer a terse response. -8.61e+06. In the year 1999, what is the difference between the Aid flow (current US$) in European Union and Aid flow (current US$) in Lithuania?
Provide a succinct answer. 5.95e+06. In the year 1999, what is the difference between the Aid flow (current US$) of European Union and Aid flow (current US$) of Myanmar?
Keep it short and to the point. 5.85e+06. In the year 1999, what is the difference between the Aid flow (current US$) of European Union and Aid flow (current US$) of Namibia?
Your answer should be very brief. 2.41e+06. In the year 1999, what is the difference between the Aid flow (current US$) in Lithuania and Aid flow (current US$) in Myanmar?
Your answer should be compact. -1.00e+05. In the year 1999, what is the difference between the Aid flow (current US$) in Lithuania and Aid flow (current US$) in Namibia?
Provide a succinct answer. -3.54e+06. In the year 1999, what is the difference between the Aid flow (current US$) of Myanmar and Aid flow (current US$) of Namibia?
Keep it short and to the point. -3.44e+06. In the year 2000, what is the difference between the Aid flow (current US$) of European Union and Aid flow (current US$) of Lithuania?
Give a very brief answer. 6.39e+06. In the year 2000, what is the difference between the Aid flow (current US$) in European Union and Aid flow (current US$) in Myanmar?
Make the answer very short. 5.24e+06. In the year 2000, what is the difference between the Aid flow (current US$) in European Union and Aid flow (current US$) in Namibia?
Make the answer very short. 9.60e+05. In the year 2000, what is the difference between the Aid flow (current US$) of Lithuania and Aid flow (current US$) of Myanmar?
Keep it short and to the point. -1.15e+06. In the year 2000, what is the difference between the Aid flow (current US$) of Lithuania and Aid flow (current US$) of Namibia?
Make the answer very short. -5.43e+06. In the year 2000, what is the difference between the Aid flow (current US$) in Myanmar and Aid flow (current US$) in Namibia?
Give a very brief answer. -4.28e+06. In the year 2001, what is the difference between the Aid flow (current US$) of European Union and Aid flow (current US$) of Lithuania?
Give a very brief answer. 2.23e+07. In the year 2001, what is the difference between the Aid flow (current US$) of European Union and Aid flow (current US$) of Myanmar?
Provide a short and direct response. 2.01e+07. In the year 2001, what is the difference between the Aid flow (current US$) in European Union and Aid flow (current US$) in Namibia?
Your answer should be compact. 1.92e+07. In the year 2001, what is the difference between the Aid flow (current US$) of Lithuania and Aid flow (current US$) of Myanmar?
Make the answer very short. -2.27e+06. In the year 2001, what is the difference between the Aid flow (current US$) in Lithuania and Aid flow (current US$) in Namibia?
Offer a very short reply. -3.14e+06. In the year 2001, what is the difference between the Aid flow (current US$) in Myanmar and Aid flow (current US$) in Namibia?
Provide a short and direct response. -8.70e+05. What is the ratio of the Aid flow (current US$) in European Union in 1994 to that in 1995?
Your response must be concise. 2.67. What is the ratio of the Aid flow (current US$) in Lithuania in 1994 to that in 1995?
Provide a short and direct response. 1.48. What is the ratio of the Aid flow (current US$) of Myanmar in 1994 to that in 1995?
Offer a terse response. 0.88. What is the ratio of the Aid flow (current US$) in Namibia in 1994 to that in 1995?
Keep it short and to the point. 1.06. What is the ratio of the Aid flow (current US$) of European Union in 1994 to that in 1996?
Provide a short and direct response. 2.2. What is the ratio of the Aid flow (current US$) in Lithuania in 1994 to that in 1996?
Offer a terse response. 1.51. What is the ratio of the Aid flow (current US$) of Myanmar in 1994 to that in 1996?
Ensure brevity in your answer.  0.61. What is the ratio of the Aid flow (current US$) in Namibia in 1994 to that in 1996?
Offer a very short reply. 0.69. What is the ratio of the Aid flow (current US$) in European Union in 1994 to that in 1997?
Ensure brevity in your answer.  2.12. What is the ratio of the Aid flow (current US$) of Lithuania in 1994 to that in 1997?
Give a very brief answer. 1.17. What is the ratio of the Aid flow (current US$) in Myanmar in 1994 to that in 1997?
Keep it short and to the point. 0.45. What is the ratio of the Aid flow (current US$) of Namibia in 1994 to that in 1997?
Your answer should be compact. 0.96. What is the ratio of the Aid flow (current US$) of European Union in 1994 to that in 1998?
Provide a short and direct response. 1.83. What is the ratio of the Aid flow (current US$) in Lithuania in 1994 to that in 1998?
Your response must be concise. 1.02. What is the ratio of the Aid flow (current US$) in Myanmar in 1994 to that in 1998?
Your response must be concise. 0.31. What is the ratio of the Aid flow (current US$) of Namibia in 1994 to that in 1998?
Keep it short and to the point. 1.04. What is the ratio of the Aid flow (current US$) in European Union in 1994 to that in 1999?
Offer a very short reply. 5.24. What is the ratio of the Aid flow (current US$) in Lithuania in 1994 to that in 1999?
Offer a terse response. 1.8. What is the ratio of the Aid flow (current US$) in Myanmar in 1994 to that in 1999?
Offer a terse response. 0.39. What is the ratio of the Aid flow (current US$) of Namibia in 1994 to that in 1999?
Offer a very short reply. 2.13. What is the ratio of the Aid flow (current US$) of European Union in 1994 to that in 2000?
Your answer should be very brief. 5.01. What is the ratio of the Aid flow (current US$) of Lithuania in 1994 to that in 2000?
Give a very brief answer. 1.88. What is the ratio of the Aid flow (current US$) in Myanmar in 1994 to that in 2000?
Offer a very short reply. 0.26. What is the ratio of the Aid flow (current US$) of Namibia in 1994 to that in 2000?
Ensure brevity in your answer.  1.59. What is the ratio of the Aid flow (current US$) of European Union in 1994 to that in 2001?
Keep it short and to the point. 1.78. What is the ratio of the Aid flow (current US$) in Lithuania in 1994 to that in 2001?
Your answer should be compact. 5.7. What is the ratio of the Aid flow (current US$) in Myanmar in 1994 to that in 2001?
Provide a short and direct response. 0.26. What is the ratio of the Aid flow (current US$) of Namibia in 1994 to that in 2001?
Ensure brevity in your answer.  3.07. What is the ratio of the Aid flow (current US$) in European Union in 1995 to that in 1996?
Provide a succinct answer. 0.82. What is the ratio of the Aid flow (current US$) in Lithuania in 1995 to that in 1996?
Give a very brief answer. 1.02. What is the ratio of the Aid flow (current US$) of Myanmar in 1995 to that in 1996?
Offer a very short reply. 0.69. What is the ratio of the Aid flow (current US$) of Namibia in 1995 to that in 1996?
Keep it short and to the point. 0.65. What is the ratio of the Aid flow (current US$) in European Union in 1995 to that in 1997?
Give a very brief answer. 0.79. What is the ratio of the Aid flow (current US$) of Lithuania in 1995 to that in 1997?
Your response must be concise. 0.79. What is the ratio of the Aid flow (current US$) of Myanmar in 1995 to that in 1997?
Offer a very short reply. 0.52. What is the ratio of the Aid flow (current US$) in Namibia in 1995 to that in 1997?
Provide a succinct answer. 0.91. What is the ratio of the Aid flow (current US$) of European Union in 1995 to that in 1998?
Ensure brevity in your answer.  0.68. What is the ratio of the Aid flow (current US$) of Lithuania in 1995 to that in 1998?
Keep it short and to the point. 0.69. What is the ratio of the Aid flow (current US$) in Myanmar in 1995 to that in 1998?
Give a very brief answer. 0.36. What is the ratio of the Aid flow (current US$) of Namibia in 1995 to that in 1998?
Your response must be concise. 0.98. What is the ratio of the Aid flow (current US$) of European Union in 1995 to that in 1999?
Provide a short and direct response. 1.96. What is the ratio of the Aid flow (current US$) of Lithuania in 1995 to that in 1999?
Your answer should be very brief. 1.22. What is the ratio of the Aid flow (current US$) in Myanmar in 1995 to that in 1999?
Your response must be concise. 0.44. What is the ratio of the Aid flow (current US$) in Namibia in 1995 to that in 1999?
Make the answer very short. 2.02. What is the ratio of the Aid flow (current US$) of European Union in 1995 to that in 2000?
Offer a very short reply. 1.87. What is the ratio of the Aid flow (current US$) in Lithuania in 1995 to that in 2000?
Your response must be concise. 1.27. What is the ratio of the Aid flow (current US$) in Myanmar in 1995 to that in 2000?
Provide a succinct answer. 0.29. What is the ratio of the Aid flow (current US$) in Namibia in 1995 to that in 2000?
Your answer should be very brief. 1.51. What is the ratio of the Aid flow (current US$) of European Union in 1995 to that in 2001?
Your response must be concise. 0.66. What is the ratio of the Aid flow (current US$) in Lithuania in 1995 to that in 2001?
Offer a terse response. 3.86. What is the ratio of the Aid flow (current US$) of Myanmar in 1995 to that in 2001?
Offer a terse response. 0.3. What is the ratio of the Aid flow (current US$) in Namibia in 1995 to that in 2001?
Provide a short and direct response. 2.91. What is the ratio of the Aid flow (current US$) in European Union in 1996 to that in 1997?
Keep it short and to the point. 0.97. What is the ratio of the Aid flow (current US$) in Lithuania in 1996 to that in 1997?
Your answer should be compact. 0.77. What is the ratio of the Aid flow (current US$) in Myanmar in 1996 to that in 1997?
Give a very brief answer. 0.74. What is the ratio of the Aid flow (current US$) in Namibia in 1996 to that in 1997?
Offer a very short reply. 1.4. What is the ratio of the Aid flow (current US$) of European Union in 1996 to that in 1998?
Offer a terse response. 0.83. What is the ratio of the Aid flow (current US$) in Lithuania in 1996 to that in 1998?
Provide a succinct answer. 0.67. What is the ratio of the Aid flow (current US$) of Myanmar in 1996 to that in 1998?
Provide a short and direct response. 0.51. What is the ratio of the Aid flow (current US$) in Namibia in 1996 to that in 1998?
Your response must be concise. 1.51. What is the ratio of the Aid flow (current US$) in European Union in 1996 to that in 1999?
Provide a short and direct response. 2.39. What is the ratio of the Aid flow (current US$) of Lithuania in 1996 to that in 1999?
Provide a short and direct response. 1.19. What is the ratio of the Aid flow (current US$) of Myanmar in 1996 to that in 1999?
Your answer should be very brief. 0.63. What is the ratio of the Aid flow (current US$) of Namibia in 1996 to that in 1999?
Provide a short and direct response. 3.1. What is the ratio of the Aid flow (current US$) of European Union in 1996 to that in 2000?
Provide a short and direct response. 2.28. What is the ratio of the Aid flow (current US$) of Lithuania in 1996 to that in 2000?
Your answer should be very brief. 1.24. What is the ratio of the Aid flow (current US$) of Myanmar in 1996 to that in 2000?
Ensure brevity in your answer.  0.42. What is the ratio of the Aid flow (current US$) in Namibia in 1996 to that in 2000?
Provide a succinct answer. 2.32. What is the ratio of the Aid flow (current US$) of European Union in 1996 to that in 2001?
Provide a succinct answer. 0.81. What is the ratio of the Aid flow (current US$) in Lithuania in 1996 to that in 2001?
Provide a succinct answer. 3.77. What is the ratio of the Aid flow (current US$) of Myanmar in 1996 to that in 2001?
Your answer should be compact. 0.43. What is the ratio of the Aid flow (current US$) in Namibia in 1996 to that in 2001?
Provide a succinct answer. 4.47. What is the ratio of the Aid flow (current US$) in European Union in 1997 to that in 1998?
Ensure brevity in your answer.  0.86. What is the ratio of the Aid flow (current US$) of Lithuania in 1997 to that in 1998?
Offer a terse response. 0.87. What is the ratio of the Aid flow (current US$) in Myanmar in 1997 to that in 1998?
Provide a succinct answer. 0.69. What is the ratio of the Aid flow (current US$) of Namibia in 1997 to that in 1998?
Provide a short and direct response. 1.08. What is the ratio of the Aid flow (current US$) of European Union in 1997 to that in 1999?
Offer a very short reply. 2.47. What is the ratio of the Aid flow (current US$) of Lithuania in 1997 to that in 1999?
Offer a terse response. 1.54. What is the ratio of the Aid flow (current US$) in Myanmar in 1997 to that in 1999?
Provide a short and direct response. 0.85. What is the ratio of the Aid flow (current US$) of Namibia in 1997 to that in 1999?
Your answer should be compact. 2.21. What is the ratio of the Aid flow (current US$) of European Union in 1997 to that in 2000?
Offer a terse response. 2.36. What is the ratio of the Aid flow (current US$) in Lithuania in 1997 to that in 2000?
Offer a very short reply. 1.61. What is the ratio of the Aid flow (current US$) in Myanmar in 1997 to that in 2000?
Your response must be concise. 0.57. What is the ratio of the Aid flow (current US$) in Namibia in 1997 to that in 2000?
Your answer should be compact. 1.65. What is the ratio of the Aid flow (current US$) in European Union in 1997 to that in 2001?
Give a very brief answer. 0.84. What is the ratio of the Aid flow (current US$) in Lithuania in 1997 to that in 2001?
Ensure brevity in your answer.  4.88. What is the ratio of the Aid flow (current US$) of Myanmar in 1997 to that in 2001?
Provide a short and direct response. 0.57. What is the ratio of the Aid flow (current US$) in Namibia in 1997 to that in 2001?
Ensure brevity in your answer.  3.19. What is the ratio of the Aid flow (current US$) of European Union in 1998 to that in 1999?
Offer a terse response. 2.87. What is the ratio of the Aid flow (current US$) in Lithuania in 1998 to that in 1999?
Ensure brevity in your answer.  1.76. What is the ratio of the Aid flow (current US$) of Myanmar in 1998 to that in 1999?
Offer a terse response. 1.24. What is the ratio of the Aid flow (current US$) in Namibia in 1998 to that in 1999?
Your answer should be very brief. 2.05. What is the ratio of the Aid flow (current US$) of European Union in 1998 to that in 2000?
Your answer should be compact. 2.74. What is the ratio of the Aid flow (current US$) of Lithuania in 1998 to that in 2000?
Provide a short and direct response. 1.84. What is the ratio of the Aid flow (current US$) in Myanmar in 1998 to that in 2000?
Offer a very short reply. 0.82. What is the ratio of the Aid flow (current US$) in Namibia in 1998 to that in 2000?
Your answer should be compact. 1.53. What is the ratio of the Aid flow (current US$) in European Union in 1998 to that in 2001?
Your answer should be compact. 0.97. What is the ratio of the Aid flow (current US$) of Lithuania in 1998 to that in 2001?
Your response must be concise. 5.6. What is the ratio of the Aid flow (current US$) in Myanmar in 1998 to that in 2001?
Ensure brevity in your answer.  0.83. What is the ratio of the Aid flow (current US$) of Namibia in 1998 to that in 2001?
Your answer should be compact. 2.96. What is the ratio of the Aid flow (current US$) in European Union in 1999 to that in 2000?
Provide a short and direct response. 0.96. What is the ratio of the Aid flow (current US$) of Lithuania in 1999 to that in 2000?
Offer a very short reply. 1.05. What is the ratio of the Aid flow (current US$) of Myanmar in 1999 to that in 2000?
Provide a short and direct response. 0.66. What is the ratio of the Aid flow (current US$) of Namibia in 1999 to that in 2000?
Your answer should be very brief. 0.75. What is the ratio of the Aid flow (current US$) in European Union in 1999 to that in 2001?
Ensure brevity in your answer.  0.34. What is the ratio of the Aid flow (current US$) in Lithuania in 1999 to that in 2001?
Provide a short and direct response. 3.18. What is the ratio of the Aid flow (current US$) of Myanmar in 1999 to that in 2001?
Keep it short and to the point. 0.67. What is the ratio of the Aid flow (current US$) of Namibia in 1999 to that in 2001?
Ensure brevity in your answer.  1.44. What is the ratio of the Aid flow (current US$) in European Union in 2000 to that in 2001?
Offer a very short reply. 0.35. What is the ratio of the Aid flow (current US$) in Lithuania in 2000 to that in 2001?
Give a very brief answer. 3.04. What is the ratio of the Aid flow (current US$) in Myanmar in 2000 to that in 2001?
Your response must be concise. 1.01. What is the ratio of the Aid flow (current US$) in Namibia in 2000 to that in 2001?
Your response must be concise. 1.93. What is the difference between the highest and the second highest Aid flow (current US$) of European Union?
Provide a short and direct response. 1.78e+07. What is the difference between the highest and the second highest Aid flow (current US$) in Namibia?
Keep it short and to the point. 4.78e+06. What is the difference between the highest and the lowest Aid flow (current US$) of European Union?
Make the answer very short. 3.29e+07. What is the difference between the highest and the lowest Aid flow (current US$) in Lithuania?
Your response must be concise. 2.68e+06. What is the difference between the highest and the lowest Aid flow (current US$) of Myanmar?
Keep it short and to the point. 2.14e+06. What is the difference between the highest and the lowest Aid flow (current US$) in Namibia?
Offer a very short reply. 1.29e+07. 